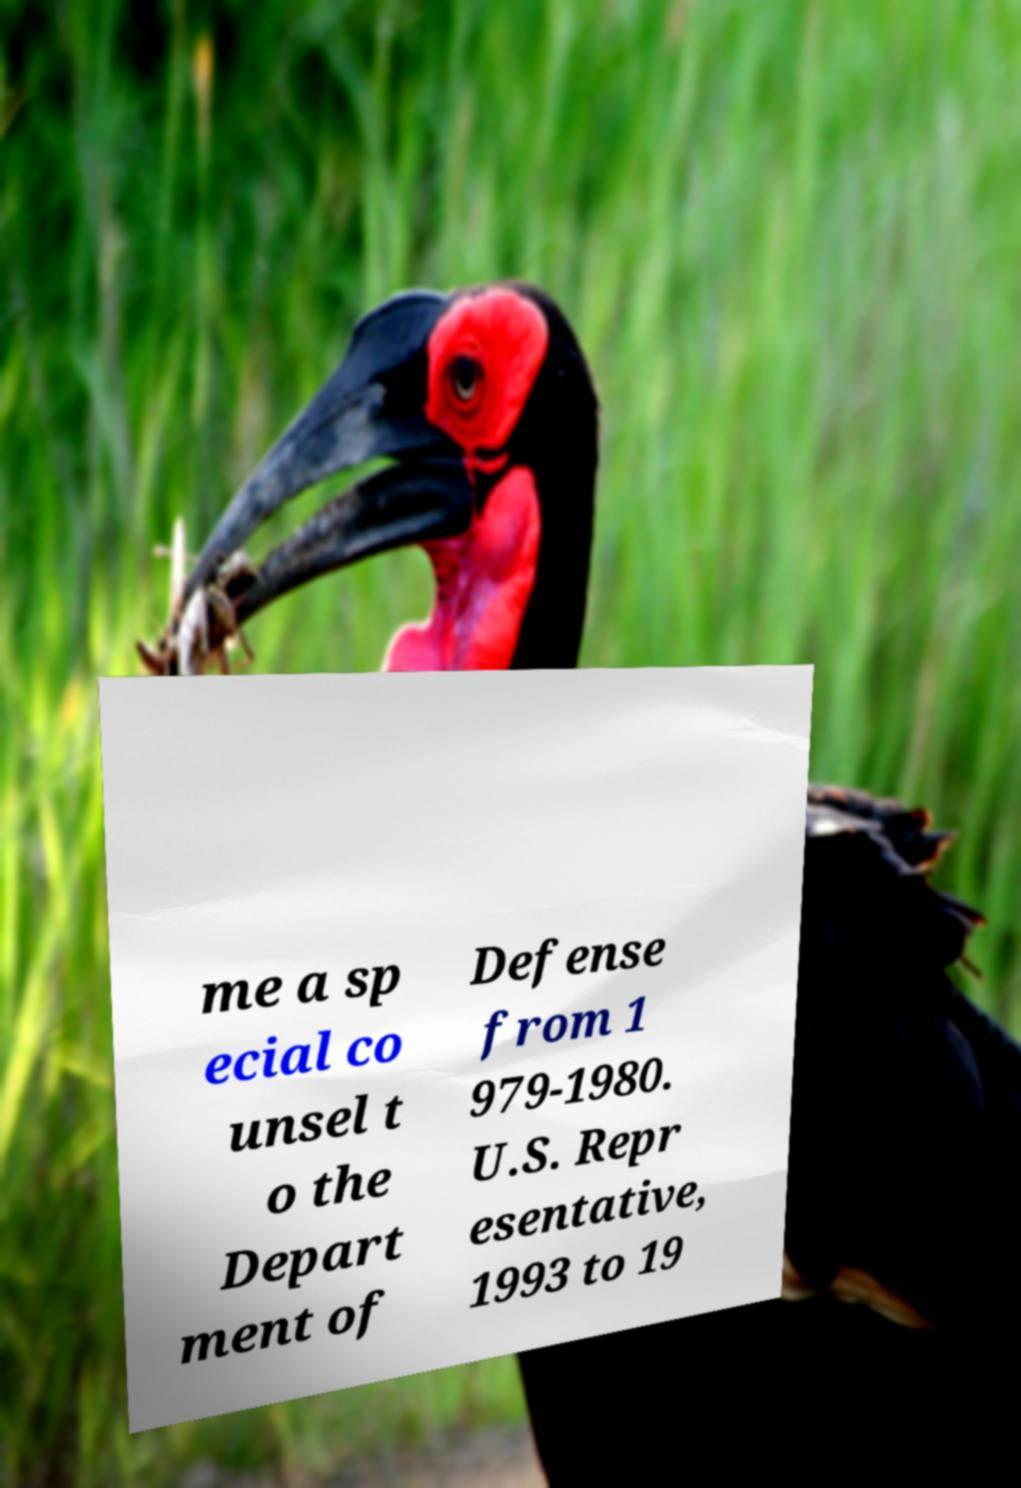I need the written content from this picture converted into text. Can you do that? me a sp ecial co unsel t o the Depart ment of Defense from 1 979-1980. U.S. Repr esentative, 1993 to 19 